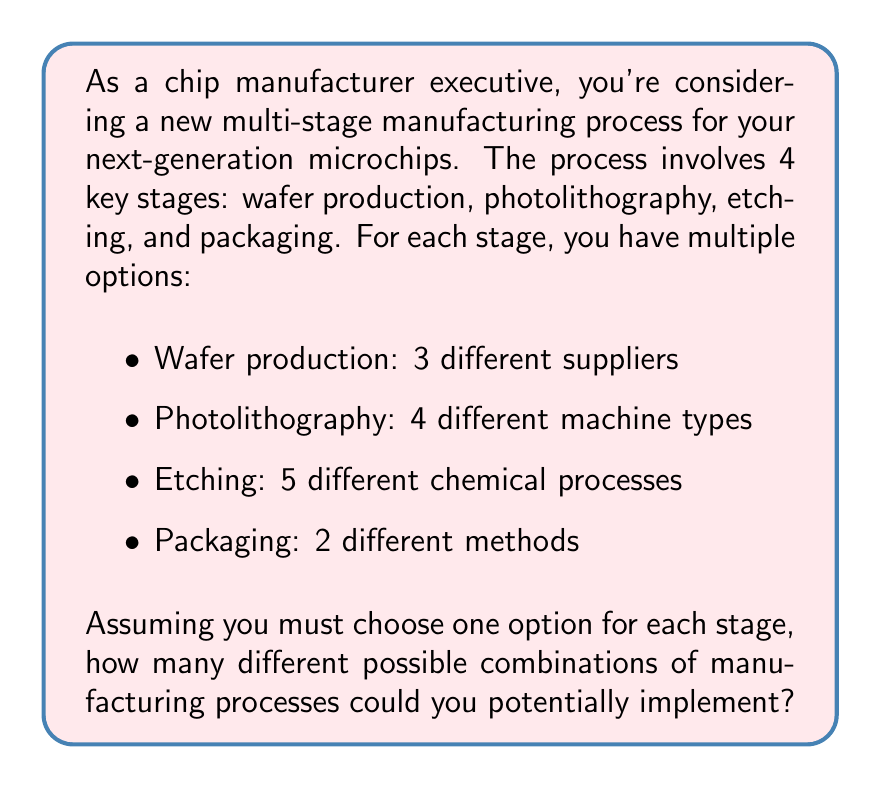Can you solve this math problem? To solve this problem, we need to use the multiplication principle of counting. This principle states that if we have a series of independent choices, where the number of options for each choice is fixed, the total number of possible outcomes is the product of the number of options for each choice.

Let's break down the problem:

1. Wafer production: 3 options
2. Photolithography: 4 options
3. Etching: 5 options
4. Packaging: 2 options

Since we must choose one option for each stage, and the choices are independent of each other, we multiply the number of options for each stage:

$$ \text{Total combinations} = 3 \times 4 \times 5 \times 2 $$

Calculating this:

$$ \text{Total combinations} = 3 \times 4 \times 5 \times 2 = 120 $$

Therefore, there are 120 different possible combinations of manufacturing processes that could be implemented.

This calculation is valuable for a chip manufacturer executive because it shows the full range of potential process configurations. It can help in strategic planning, as you may want to evaluate which of these combinations are most cost-effective, efficient, or produce the highest quality chips. It also highlights the complexity of the manufacturing process and the importance of careful selection at each stage.
Answer: $$ 120 \text{ possible combinations} $$ 